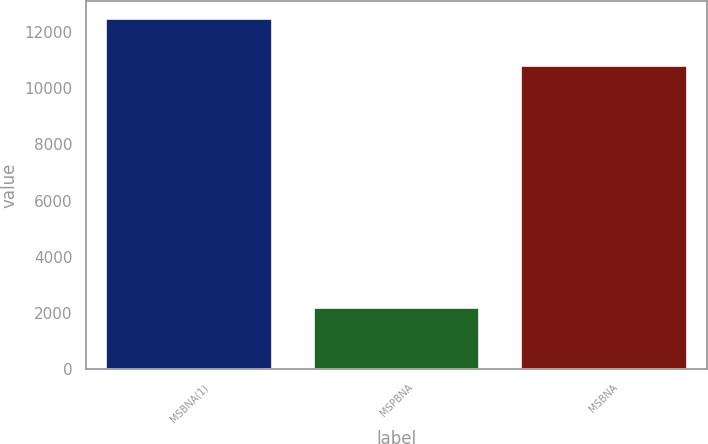<chart> <loc_0><loc_0><loc_500><loc_500><bar_chart><fcel>MSBNA(1)<fcel>MSPBNA<fcel>MSBNA<nl><fcel>12468<fcel>2184<fcel>10805<nl></chart> 